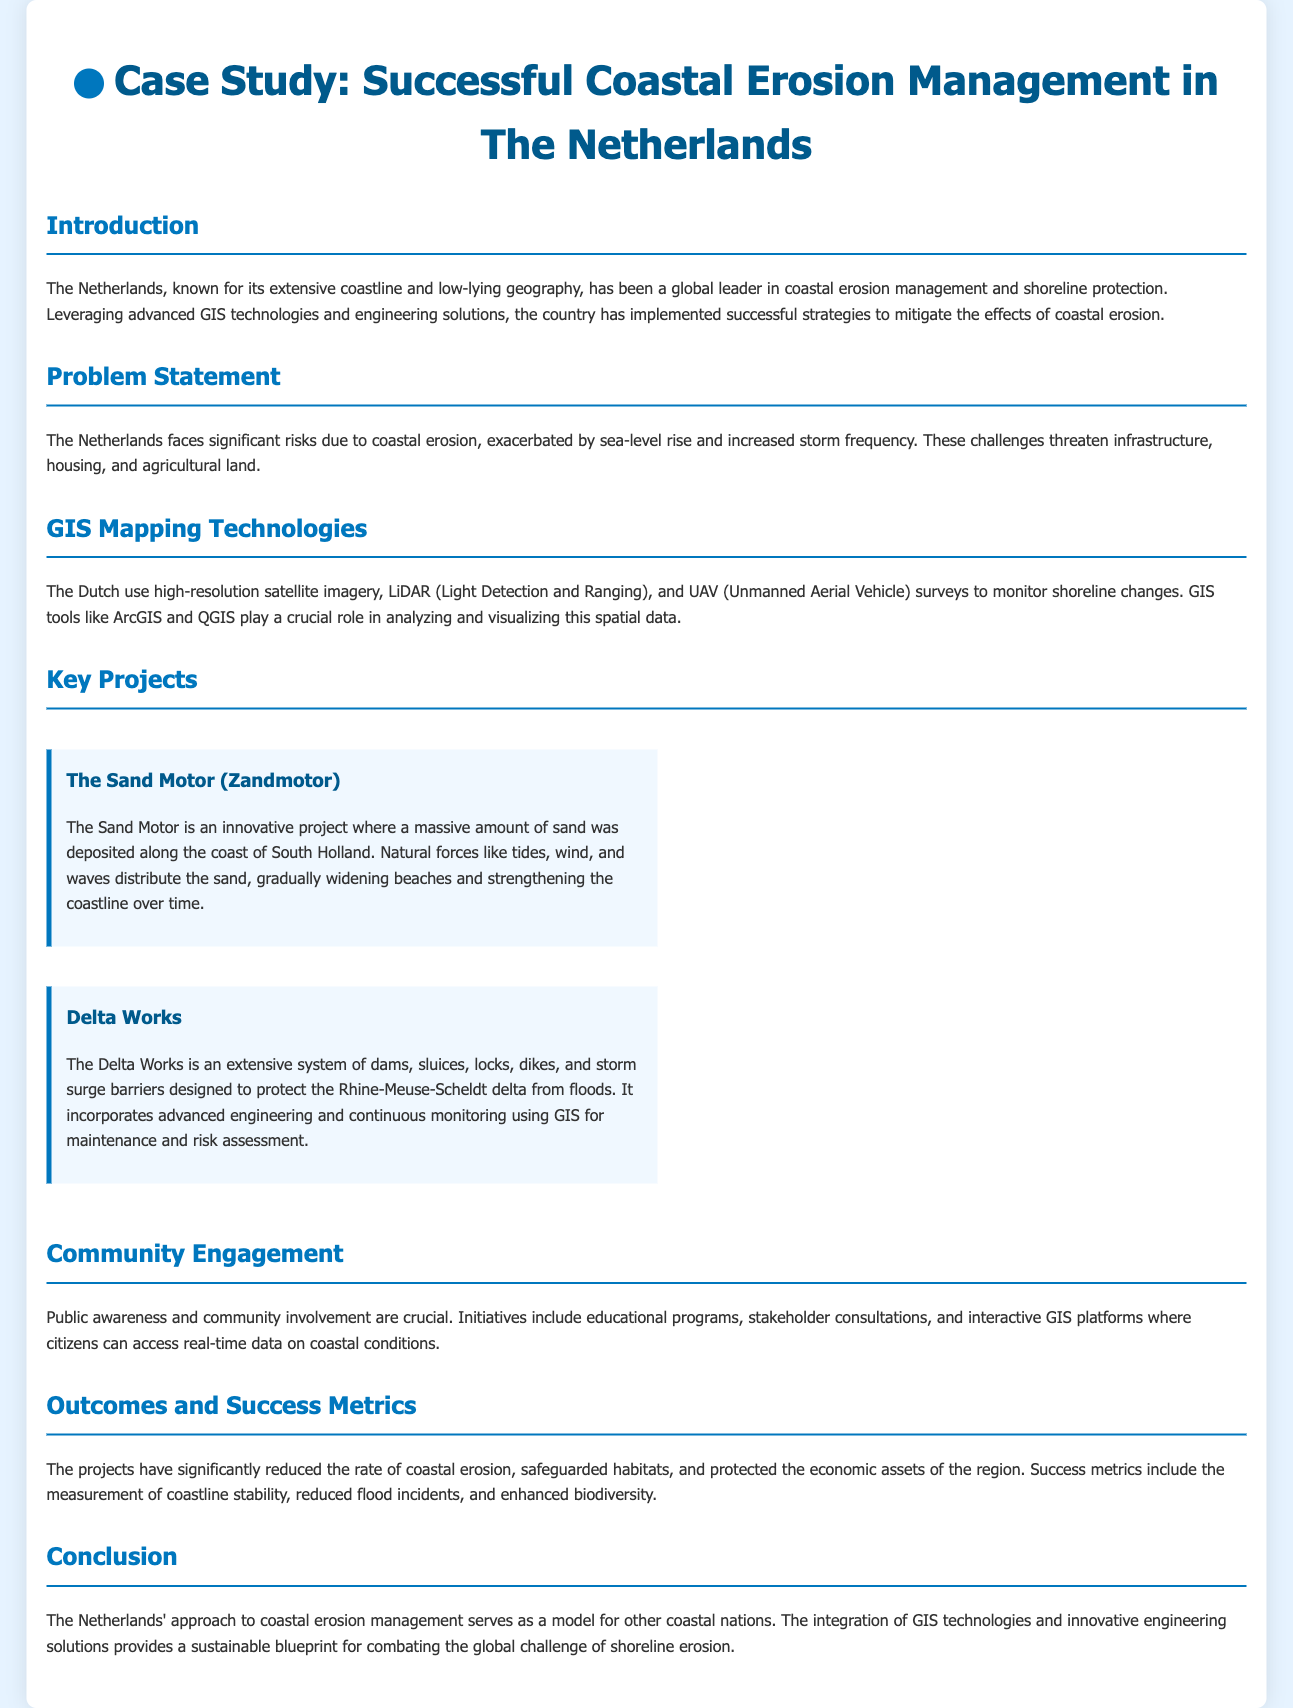what country is the case study about? The case study focuses on coastal erosion management in The Netherlands.
Answer: The Netherlands what innovative project is mentioned that enhances the coastline? The document describes The Sand Motor as an innovative coastal enhancement project.
Answer: The Sand Motor what are the main technologies used for monitoring shoreline changes? High-resolution satellite imagery, LiDAR, and UAV surveys are the technologies utilized for monitoring.
Answer: Satellite imagery, LiDAR, UAV what is the extensive system designed to protect against floods called? The Delta Works is the name of the system designed to protect the Rhine-Meuse-Scheldt delta.
Answer: Delta Works how does the Netherlands engage with the community? Community engagement initiatives include educational programs and stakeholder consultations.
Answer: Educational programs, stakeholder consultations what are the outcomes measured in the coastal erosion management projects? The success metrics include coastline stability, reduced flood incidents, and enhanced biodiversity.
Answer: Coastline stability, reduced flood incidents, enhanced biodiversity what is one of the main challenges that exacerbate coastal erosion? Sea-level rise is identified as one of the main challenges affecting coastal erosion.
Answer: Sea-level rise in which region of The Netherlands is The Sand Motor located? The Sand Motor is specifically located along the coast of South Holland.
Answer: South Holland what is the purpose of the GIS tools mentioned? GIS tools like ArcGIS and QGIS are used for analyzing and visualizing spatial data.
Answer: Analyzing and visualizing spatial data 